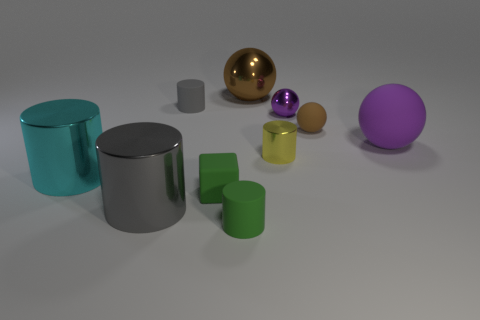Subtract all rubber cylinders. How many cylinders are left? 3 Subtract all cyan cylinders. How many brown spheres are left? 2 Subtract all purple spheres. How many spheres are left? 2 Subtract 1 cylinders. How many cylinders are left? 4 Subtract all spheres. How many objects are left? 6 Add 5 large matte things. How many large matte things are left? 6 Add 2 big yellow rubber cubes. How many big yellow rubber cubes exist? 2 Subtract 0 yellow spheres. How many objects are left? 10 Subtract all red spheres. Subtract all cyan cylinders. How many spheres are left? 4 Subtract all big red rubber cylinders. Subtract all rubber blocks. How many objects are left? 9 